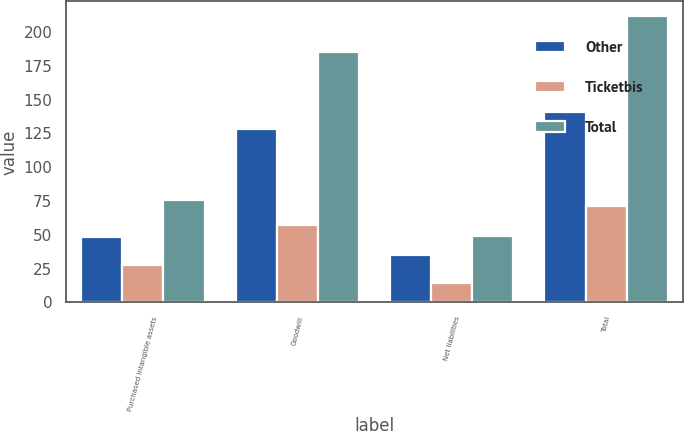<chart> <loc_0><loc_0><loc_500><loc_500><stacked_bar_chart><ecel><fcel>Purchased intangible assets<fcel>Goodwill<fcel>Net liabilities<fcel>Total<nl><fcel>Other<fcel>48<fcel>128<fcel>35<fcel>141<nl><fcel>Ticketbis<fcel>28<fcel>57<fcel>14<fcel>71<nl><fcel>Total<fcel>76<fcel>185<fcel>49<fcel>212<nl></chart> 